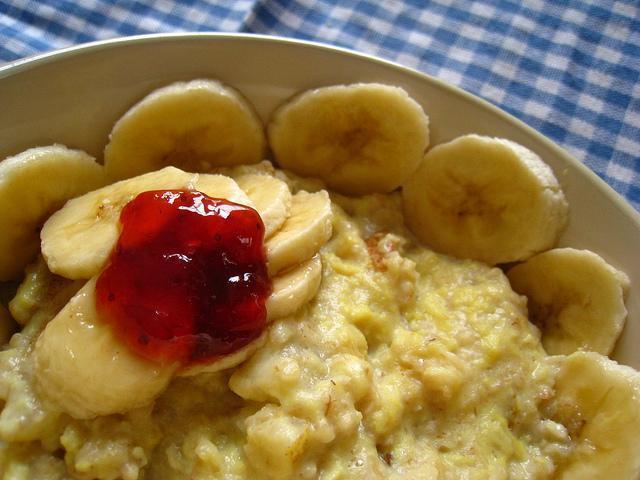How many bananas are visible?
Give a very brief answer. 7. 